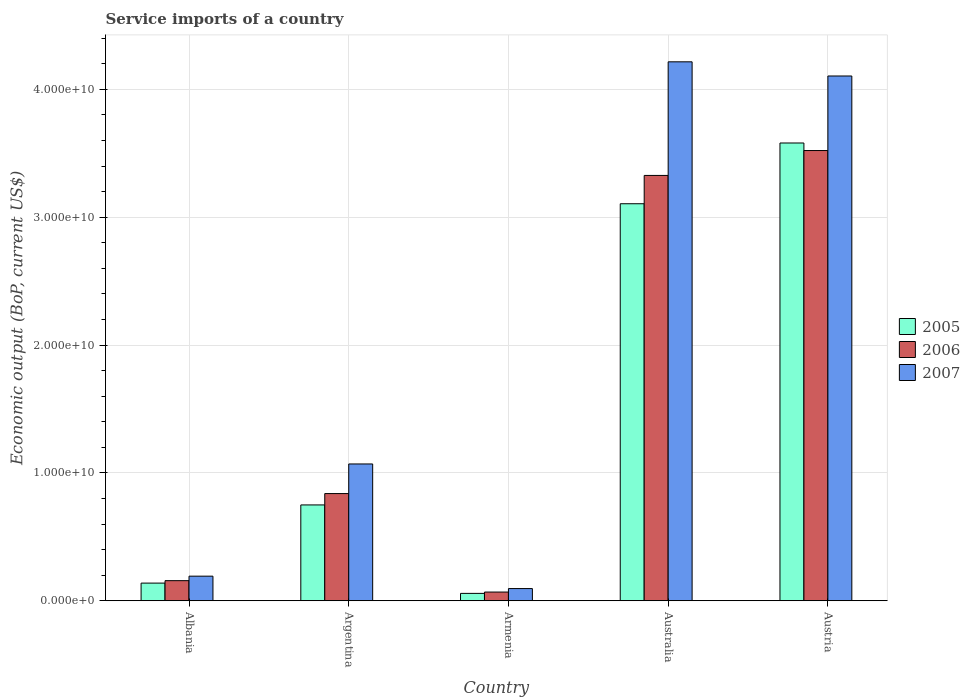How many different coloured bars are there?
Your response must be concise. 3. How many groups of bars are there?
Your answer should be compact. 5. What is the service imports in 2007 in Argentina?
Keep it short and to the point. 1.07e+1. Across all countries, what is the maximum service imports in 2005?
Provide a short and direct response. 3.58e+1. Across all countries, what is the minimum service imports in 2007?
Make the answer very short. 9.54e+08. In which country was the service imports in 2006 minimum?
Provide a short and direct response. Armenia. What is the total service imports in 2007 in the graph?
Your response must be concise. 9.68e+1. What is the difference between the service imports in 2007 in Argentina and that in Armenia?
Offer a very short reply. 9.75e+09. What is the difference between the service imports in 2007 in Armenia and the service imports in 2005 in Argentina?
Provide a short and direct response. -6.54e+09. What is the average service imports in 2006 per country?
Offer a very short reply. 1.58e+1. What is the difference between the service imports of/in 2006 and service imports of/in 2007 in Albania?
Offer a terse response. -3.51e+08. What is the ratio of the service imports in 2006 in Argentina to that in Armenia?
Offer a very short reply. 12.3. What is the difference between the highest and the second highest service imports in 2005?
Offer a terse response. -4.75e+09. What is the difference between the highest and the lowest service imports in 2006?
Ensure brevity in your answer.  3.45e+1. In how many countries, is the service imports in 2006 greater than the average service imports in 2006 taken over all countries?
Make the answer very short. 2. What does the 1st bar from the right in Armenia represents?
Ensure brevity in your answer.  2007. Is it the case that in every country, the sum of the service imports in 2006 and service imports in 2005 is greater than the service imports in 2007?
Make the answer very short. Yes. How many countries are there in the graph?
Give a very brief answer. 5. What is the difference between two consecutive major ticks on the Y-axis?
Provide a succinct answer. 1.00e+1. Are the values on the major ticks of Y-axis written in scientific E-notation?
Provide a succinct answer. Yes. Does the graph contain grids?
Your answer should be very brief. Yes. Where does the legend appear in the graph?
Provide a succinct answer. Center right. How many legend labels are there?
Your answer should be compact. 3. How are the legend labels stacked?
Your answer should be compact. Vertical. What is the title of the graph?
Your answer should be very brief. Service imports of a country. Does "2010" appear as one of the legend labels in the graph?
Your response must be concise. No. What is the label or title of the Y-axis?
Your answer should be compact. Economic output (BoP, current US$). What is the Economic output (BoP, current US$) of 2005 in Albania?
Provide a succinct answer. 1.38e+09. What is the Economic output (BoP, current US$) in 2006 in Albania?
Ensure brevity in your answer.  1.57e+09. What is the Economic output (BoP, current US$) of 2007 in Albania?
Your answer should be very brief. 1.92e+09. What is the Economic output (BoP, current US$) of 2005 in Argentina?
Your answer should be very brief. 7.50e+09. What is the Economic output (BoP, current US$) in 2006 in Argentina?
Keep it short and to the point. 8.39e+09. What is the Economic output (BoP, current US$) in 2007 in Argentina?
Give a very brief answer. 1.07e+1. What is the Economic output (BoP, current US$) in 2005 in Armenia?
Ensure brevity in your answer.  5.78e+08. What is the Economic output (BoP, current US$) of 2006 in Armenia?
Give a very brief answer. 6.82e+08. What is the Economic output (BoP, current US$) of 2007 in Armenia?
Provide a succinct answer. 9.54e+08. What is the Economic output (BoP, current US$) in 2005 in Australia?
Provide a short and direct response. 3.11e+1. What is the Economic output (BoP, current US$) in 2006 in Australia?
Give a very brief answer. 3.33e+1. What is the Economic output (BoP, current US$) of 2007 in Australia?
Your answer should be very brief. 4.22e+1. What is the Economic output (BoP, current US$) of 2005 in Austria?
Your response must be concise. 3.58e+1. What is the Economic output (BoP, current US$) in 2006 in Austria?
Keep it short and to the point. 3.52e+1. What is the Economic output (BoP, current US$) in 2007 in Austria?
Offer a very short reply. 4.10e+1. Across all countries, what is the maximum Economic output (BoP, current US$) of 2005?
Make the answer very short. 3.58e+1. Across all countries, what is the maximum Economic output (BoP, current US$) of 2006?
Provide a succinct answer. 3.52e+1. Across all countries, what is the maximum Economic output (BoP, current US$) in 2007?
Your answer should be compact. 4.22e+1. Across all countries, what is the minimum Economic output (BoP, current US$) of 2005?
Offer a very short reply. 5.78e+08. Across all countries, what is the minimum Economic output (BoP, current US$) of 2006?
Offer a terse response. 6.82e+08. Across all countries, what is the minimum Economic output (BoP, current US$) of 2007?
Offer a very short reply. 9.54e+08. What is the total Economic output (BoP, current US$) of 2005 in the graph?
Your response must be concise. 7.63e+1. What is the total Economic output (BoP, current US$) of 2006 in the graph?
Make the answer very short. 7.91e+1. What is the total Economic output (BoP, current US$) in 2007 in the graph?
Keep it short and to the point. 9.68e+1. What is the difference between the Economic output (BoP, current US$) in 2005 in Albania and that in Argentina?
Ensure brevity in your answer.  -6.11e+09. What is the difference between the Economic output (BoP, current US$) of 2006 in Albania and that in Argentina?
Ensure brevity in your answer.  -6.81e+09. What is the difference between the Economic output (BoP, current US$) of 2007 in Albania and that in Argentina?
Ensure brevity in your answer.  -8.78e+09. What is the difference between the Economic output (BoP, current US$) of 2005 in Albania and that in Armenia?
Offer a very short reply. 8.05e+08. What is the difference between the Economic output (BoP, current US$) of 2006 in Albania and that in Armenia?
Offer a very short reply. 8.91e+08. What is the difference between the Economic output (BoP, current US$) in 2007 in Albania and that in Armenia?
Offer a terse response. 9.70e+08. What is the difference between the Economic output (BoP, current US$) in 2005 in Albania and that in Australia?
Make the answer very short. -2.97e+1. What is the difference between the Economic output (BoP, current US$) in 2006 in Albania and that in Australia?
Provide a succinct answer. -3.17e+1. What is the difference between the Economic output (BoP, current US$) of 2007 in Albania and that in Australia?
Provide a short and direct response. -4.02e+1. What is the difference between the Economic output (BoP, current US$) of 2005 in Albania and that in Austria?
Your response must be concise. -3.44e+1. What is the difference between the Economic output (BoP, current US$) in 2006 in Albania and that in Austria?
Keep it short and to the point. -3.36e+1. What is the difference between the Economic output (BoP, current US$) in 2007 in Albania and that in Austria?
Your answer should be compact. -3.91e+1. What is the difference between the Economic output (BoP, current US$) in 2005 in Argentina and that in Armenia?
Your response must be concise. 6.92e+09. What is the difference between the Economic output (BoP, current US$) in 2006 in Argentina and that in Armenia?
Provide a short and direct response. 7.70e+09. What is the difference between the Economic output (BoP, current US$) of 2007 in Argentina and that in Armenia?
Provide a short and direct response. 9.75e+09. What is the difference between the Economic output (BoP, current US$) in 2005 in Argentina and that in Australia?
Provide a succinct answer. -2.36e+1. What is the difference between the Economic output (BoP, current US$) of 2006 in Argentina and that in Australia?
Your response must be concise. -2.49e+1. What is the difference between the Economic output (BoP, current US$) of 2007 in Argentina and that in Australia?
Provide a short and direct response. -3.15e+1. What is the difference between the Economic output (BoP, current US$) in 2005 in Argentina and that in Austria?
Your answer should be compact. -2.83e+1. What is the difference between the Economic output (BoP, current US$) in 2006 in Argentina and that in Austria?
Keep it short and to the point. -2.68e+1. What is the difference between the Economic output (BoP, current US$) in 2007 in Argentina and that in Austria?
Your answer should be very brief. -3.03e+1. What is the difference between the Economic output (BoP, current US$) of 2005 in Armenia and that in Australia?
Offer a terse response. -3.05e+1. What is the difference between the Economic output (BoP, current US$) in 2006 in Armenia and that in Australia?
Provide a succinct answer. -3.26e+1. What is the difference between the Economic output (BoP, current US$) in 2007 in Armenia and that in Australia?
Offer a terse response. -4.12e+1. What is the difference between the Economic output (BoP, current US$) in 2005 in Armenia and that in Austria?
Provide a succinct answer. -3.52e+1. What is the difference between the Economic output (BoP, current US$) of 2006 in Armenia and that in Austria?
Ensure brevity in your answer.  -3.45e+1. What is the difference between the Economic output (BoP, current US$) in 2007 in Armenia and that in Austria?
Keep it short and to the point. -4.01e+1. What is the difference between the Economic output (BoP, current US$) of 2005 in Australia and that in Austria?
Make the answer very short. -4.75e+09. What is the difference between the Economic output (BoP, current US$) of 2006 in Australia and that in Austria?
Offer a terse response. -1.95e+09. What is the difference between the Economic output (BoP, current US$) of 2007 in Australia and that in Austria?
Provide a short and direct response. 1.11e+09. What is the difference between the Economic output (BoP, current US$) of 2005 in Albania and the Economic output (BoP, current US$) of 2006 in Argentina?
Give a very brief answer. -7.00e+09. What is the difference between the Economic output (BoP, current US$) of 2005 in Albania and the Economic output (BoP, current US$) of 2007 in Argentina?
Your answer should be very brief. -9.32e+09. What is the difference between the Economic output (BoP, current US$) of 2006 in Albania and the Economic output (BoP, current US$) of 2007 in Argentina?
Ensure brevity in your answer.  -9.13e+09. What is the difference between the Economic output (BoP, current US$) of 2005 in Albania and the Economic output (BoP, current US$) of 2006 in Armenia?
Keep it short and to the point. 7.01e+08. What is the difference between the Economic output (BoP, current US$) in 2005 in Albania and the Economic output (BoP, current US$) in 2007 in Armenia?
Provide a succinct answer. 4.29e+08. What is the difference between the Economic output (BoP, current US$) in 2006 in Albania and the Economic output (BoP, current US$) in 2007 in Armenia?
Provide a short and direct response. 6.19e+08. What is the difference between the Economic output (BoP, current US$) in 2005 in Albania and the Economic output (BoP, current US$) in 2006 in Australia?
Provide a succinct answer. -3.19e+1. What is the difference between the Economic output (BoP, current US$) in 2005 in Albania and the Economic output (BoP, current US$) in 2007 in Australia?
Make the answer very short. -4.08e+1. What is the difference between the Economic output (BoP, current US$) in 2006 in Albania and the Economic output (BoP, current US$) in 2007 in Australia?
Provide a succinct answer. -4.06e+1. What is the difference between the Economic output (BoP, current US$) of 2005 in Albania and the Economic output (BoP, current US$) of 2006 in Austria?
Provide a short and direct response. -3.38e+1. What is the difference between the Economic output (BoP, current US$) of 2005 in Albania and the Economic output (BoP, current US$) of 2007 in Austria?
Ensure brevity in your answer.  -3.97e+1. What is the difference between the Economic output (BoP, current US$) in 2006 in Albania and the Economic output (BoP, current US$) in 2007 in Austria?
Your response must be concise. -3.95e+1. What is the difference between the Economic output (BoP, current US$) in 2005 in Argentina and the Economic output (BoP, current US$) in 2006 in Armenia?
Ensure brevity in your answer.  6.81e+09. What is the difference between the Economic output (BoP, current US$) of 2005 in Argentina and the Economic output (BoP, current US$) of 2007 in Armenia?
Your response must be concise. 6.54e+09. What is the difference between the Economic output (BoP, current US$) in 2006 in Argentina and the Economic output (BoP, current US$) in 2007 in Armenia?
Provide a short and direct response. 7.43e+09. What is the difference between the Economic output (BoP, current US$) of 2005 in Argentina and the Economic output (BoP, current US$) of 2006 in Australia?
Ensure brevity in your answer.  -2.58e+1. What is the difference between the Economic output (BoP, current US$) in 2005 in Argentina and the Economic output (BoP, current US$) in 2007 in Australia?
Provide a succinct answer. -3.47e+1. What is the difference between the Economic output (BoP, current US$) of 2006 in Argentina and the Economic output (BoP, current US$) of 2007 in Australia?
Your answer should be compact. -3.38e+1. What is the difference between the Economic output (BoP, current US$) of 2005 in Argentina and the Economic output (BoP, current US$) of 2006 in Austria?
Provide a short and direct response. -2.77e+1. What is the difference between the Economic output (BoP, current US$) in 2005 in Argentina and the Economic output (BoP, current US$) in 2007 in Austria?
Make the answer very short. -3.35e+1. What is the difference between the Economic output (BoP, current US$) in 2006 in Argentina and the Economic output (BoP, current US$) in 2007 in Austria?
Your answer should be compact. -3.27e+1. What is the difference between the Economic output (BoP, current US$) in 2005 in Armenia and the Economic output (BoP, current US$) in 2006 in Australia?
Your answer should be compact. -3.27e+1. What is the difference between the Economic output (BoP, current US$) in 2005 in Armenia and the Economic output (BoP, current US$) in 2007 in Australia?
Your answer should be compact. -4.16e+1. What is the difference between the Economic output (BoP, current US$) of 2006 in Armenia and the Economic output (BoP, current US$) of 2007 in Australia?
Provide a short and direct response. -4.15e+1. What is the difference between the Economic output (BoP, current US$) in 2005 in Armenia and the Economic output (BoP, current US$) in 2006 in Austria?
Provide a succinct answer. -3.46e+1. What is the difference between the Economic output (BoP, current US$) of 2005 in Armenia and the Economic output (BoP, current US$) of 2007 in Austria?
Provide a succinct answer. -4.05e+1. What is the difference between the Economic output (BoP, current US$) in 2006 in Armenia and the Economic output (BoP, current US$) in 2007 in Austria?
Offer a terse response. -4.04e+1. What is the difference between the Economic output (BoP, current US$) in 2005 in Australia and the Economic output (BoP, current US$) in 2006 in Austria?
Your response must be concise. -4.16e+09. What is the difference between the Economic output (BoP, current US$) of 2005 in Australia and the Economic output (BoP, current US$) of 2007 in Austria?
Give a very brief answer. -9.99e+09. What is the difference between the Economic output (BoP, current US$) of 2006 in Australia and the Economic output (BoP, current US$) of 2007 in Austria?
Provide a succinct answer. -7.78e+09. What is the average Economic output (BoP, current US$) in 2005 per country?
Ensure brevity in your answer.  1.53e+1. What is the average Economic output (BoP, current US$) in 2006 per country?
Offer a terse response. 1.58e+1. What is the average Economic output (BoP, current US$) of 2007 per country?
Offer a very short reply. 1.94e+1. What is the difference between the Economic output (BoP, current US$) in 2005 and Economic output (BoP, current US$) in 2006 in Albania?
Your response must be concise. -1.90e+08. What is the difference between the Economic output (BoP, current US$) of 2005 and Economic output (BoP, current US$) of 2007 in Albania?
Give a very brief answer. -5.42e+08. What is the difference between the Economic output (BoP, current US$) of 2006 and Economic output (BoP, current US$) of 2007 in Albania?
Give a very brief answer. -3.51e+08. What is the difference between the Economic output (BoP, current US$) of 2005 and Economic output (BoP, current US$) of 2006 in Argentina?
Ensure brevity in your answer.  -8.89e+08. What is the difference between the Economic output (BoP, current US$) of 2005 and Economic output (BoP, current US$) of 2007 in Argentina?
Keep it short and to the point. -3.20e+09. What is the difference between the Economic output (BoP, current US$) in 2006 and Economic output (BoP, current US$) in 2007 in Argentina?
Give a very brief answer. -2.32e+09. What is the difference between the Economic output (BoP, current US$) in 2005 and Economic output (BoP, current US$) in 2006 in Armenia?
Provide a short and direct response. -1.04e+08. What is the difference between the Economic output (BoP, current US$) of 2005 and Economic output (BoP, current US$) of 2007 in Armenia?
Provide a succinct answer. -3.76e+08. What is the difference between the Economic output (BoP, current US$) of 2006 and Economic output (BoP, current US$) of 2007 in Armenia?
Ensure brevity in your answer.  -2.72e+08. What is the difference between the Economic output (BoP, current US$) of 2005 and Economic output (BoP, current US$) of 2006 in Australia?
Make the answer very short. -2.21e+09. What is the difference between the Economic output (BoP, current US$) of 2005 and Economic output (BoP, current US$) of 2007 in Australia?
Provide a succinct answer. -1.11e+1. What is the difference between the Economic output (BoP, current US$) in 2006 and Economic output (BoP, current US$) in 2007 in Australia?
Make the answer very short. -8.89e+09. What is the difference between the Economic output (BoP, current US$) in 2005 and Economic output (BoP, current US$) in 2006 in Austria?
Provide a succinct answer. 5.90e+08. What is the difference between the Economic output (BoP, current US$) in 2005 and Economic output (BoP, current US$) in 2007 in Austria?
Provide a short and direct response. -5.24e+09. What is the difference between the Economic output (BoP, current US$) in 2006 and Economic output (BoP, current US$) in 2007 in Austria?
Your answer should be very brief. -5.83e+09. What is the ratio of the Economic output (BoP, current US$) in 2005 in Albania to that in Argentina?
Your answer should be compact. 0.18. What is the ratio of the Economic output (BoP, current US$) in 2006 in Albania to that in Argentina?
Keep it short and to the point. 0.19. What is the ratio of the Economic output (BoP, current US$) of 2007 in Albania to that in Argentina?
Offer a very short reply. 0.18. What is the ratio of the Economic output (BoP, current US$) in 2005 in Albania to that in Armenia?
Offer a very short reply. 2.39. What is the ratio of the Economic output (BoP, current US$) in 2006 in Albania to that in Armenia?
Your response must be concise. 2.31. What is the ratio of the Economic output (BoP, current US$) in 2007 in Albania to that in Armenia?
Ensure brevity in your answer.  2.02. What is the ratio of the Economic output (BoP, current US$) of 2005 in Albania to that in Australia?
Your response must be concise. 0.04. What is the ratio of the Economic output (BoP, current US$) in 2006 in Albania to that in Australia?
Ensure brevity in your answer.  0.05. What is the ratio of the Economic output (BoP, current US$) of 2007 in Albania to that in Australia?
Provide a short and direct response. 0.05. What is the ratio of the Economic output (BoP, current US$) in 2005 in Albania to that in Austria?
Your answer should be compact. 0.04. What is the ratio of the Economic output (BoP, current US$) of 2006 in Albania to that in Austria?
Ensure brevity in your answer.  0.04. What is the ratio of the Economic output (BoP, current US$) of 2007 in Albania to that in Austria?
Make the answer very short. 0.05. What is the ratio of the Economic output (BoP, current US$) of 2005 in Argentina to that in Armenia?
Your answer should be very brief. 12.97. What is the ratio of the Economic output (BoP, current US$) in 2006 in Argentina to that in Armenia?
Provide a succinct answer. 12.3. What is the ratio of the Economic output (BoP, current US$) in 2007 in Argentina to that in Armenia?
Your answer should be very brief. 11.22. What is the ratio of the Economic output (BoP, current US$) in 2005 in Argentina to that in Australia?
Offer a very short reply. 0.24. What is the ratio of the Economic output (BoP, current US$) of 2006 in Argentina to that in Australia?
Offer a very short reply. 0.25. What is the ratio of the Economic output (BoP, current US$) in 2007 in Argentina to that in Australia?
Your response must be concise. 0.25. What is the ratio of the Economic output (BoP, current US$) in 2005 in Argentina to that in Austria?
Provide a short and direct response. 0.21. What is the ratio of the Economic output (BoP, current US$) in 2006 in Argentina to that in Austria?
Give a very brief answer. 0.24. What is the ratio of the Economic output (BoP, current US$) in 2007 in Argentina to that in Austria?
Your answer should be compact. 0.26. What is the ratio of the Economic output (BoP, current US$) of 2005 in Armenia to that in Australia?
Ensure brevity in your answer.  0.02. What is the ratio of the Economic output (BoP, current US$) of 2006 in Armenia to that in Australia?
Your response must be concise. 0.02. What is the ratio of the Economic output (BoP, current US$) in 2007 in Armenia to that in Australia?
Offer a terse response. 0.02. What is the ratio of the Economic output (BoP, current US$) in 2005 in Armenia to that in Austria?
Ensure brevity in your answer.  0.02. What is the ratio of the Economic output (BoP, current US$) in 2006 in Armenia to that in Austria?
Keep it short and to the point. 0.02. What is the ratio of the Economic output (BoP, current US$) in 2007 in Armenia to that in Austria?
Offer a terse response. 0.02. What is the ratio of the Economic output (BoP, current US$) in 2005 in Australia to that in Austria?
Make the answer very short. 0.87. What is the ratio of the Economic output (BoP, current US$) of 2006 in Australia to that in Austria?
Make the answer very short. 0.94. What is the difference between the highest and the second highest Economic output (BoP, current US$) in 2005?
Your response must be concise. 4.75e+09. What is the difference between the highest and the second highest Economic output (BoP, current US$) of 2006?
Offer a very short reply. 1.95e+09. What is the difference between the highest and the second highest Economic output (BoP, current US$) in 2007?
Make the answer very short. 1.11e+09. What is the difference between the highest and the lowest Economic output (BoP, current US$) in 2005?
Your answer should be compact. 3.52e+1. What is the difference between the highest and the lowest Economic output (BoP, current US$) in 2006?
Your response must be concise. 3.45e+1. What is the difference between the highest and the lowest Economic output (BoP, current US$) in 2007?
Your answer should be very brief. 4.12e+1. 